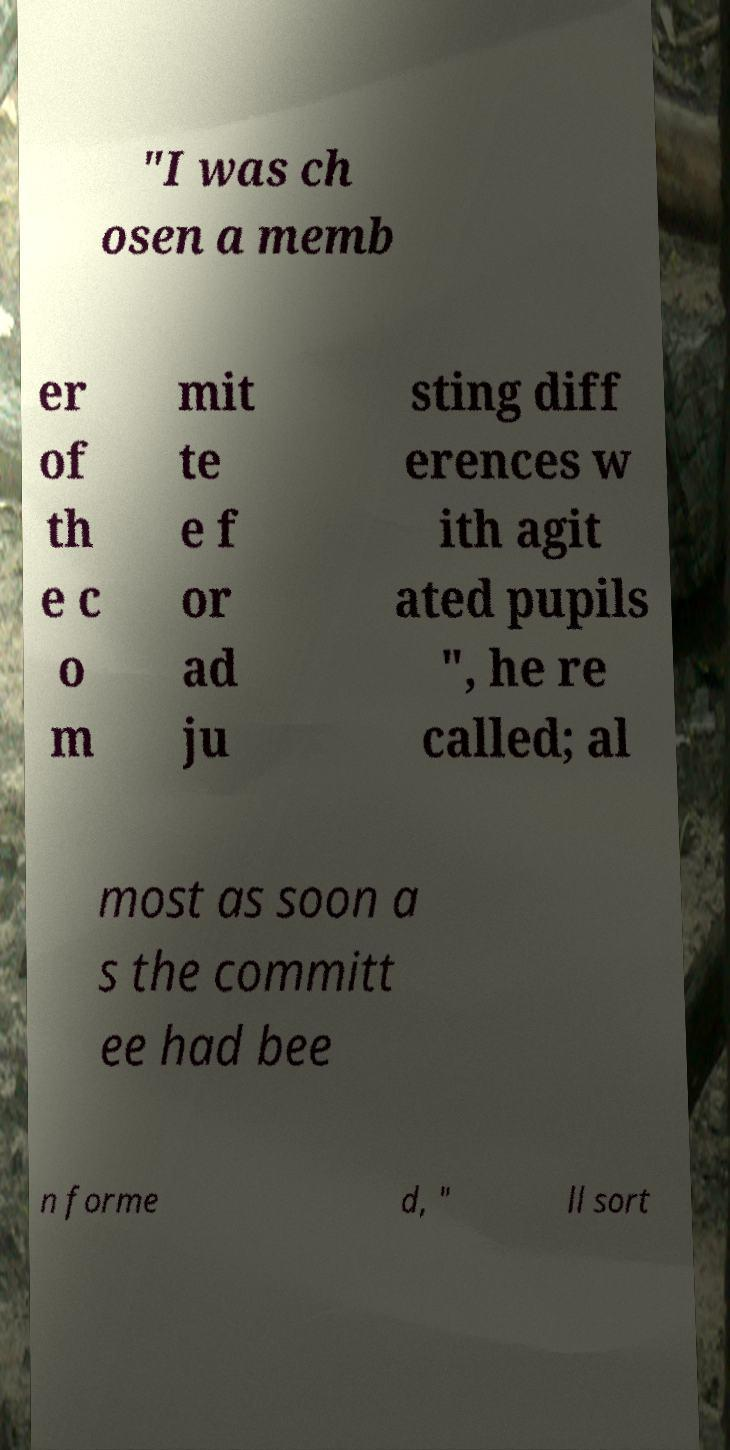For documentation purposes, I need the text within this image transcribed. Could you provide that? "I was ch osen a memb er of th e c o m mit te e f or ad ju sting diff erences w ith agit ated pupils ", he re called; al most as soon a s the committ ee had bee n forme d, " ll sort 